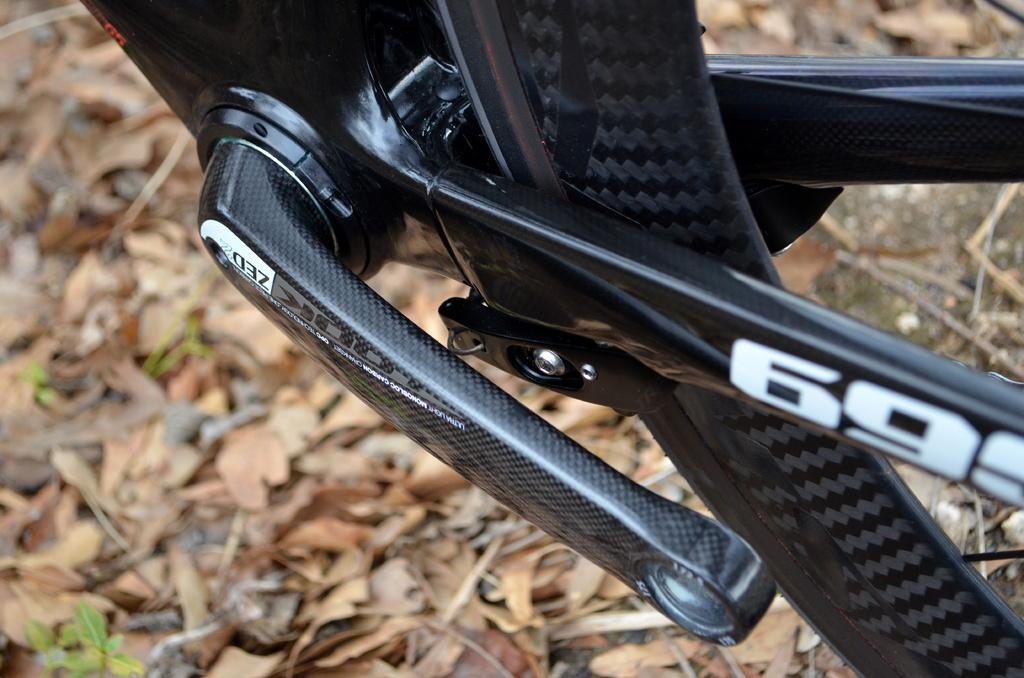What type of vehicle is partially visible in the image? The image shows the bottom part of a vehicle. What can be seen on the surface of the vehicle? There are dried leaves and small plants on the vehicle. How does the fog affect the visibility of the vehicle in the image? There is no fog present in the image, so it does not affect the visibility of the vehicle. 